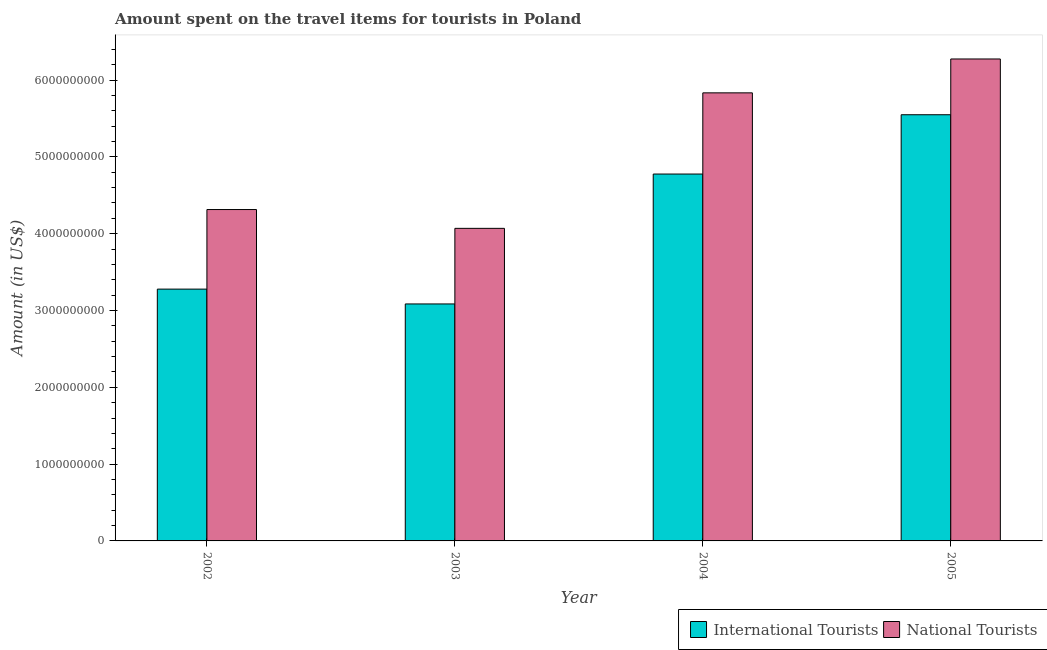Are the number of bars per tick equal to the number of legend labels?
Offer a terse response. Yes. Are the number of bars on each tick of the X-axis equal?
Your answer should be very brief. Yes. How many bars are there on the 1st tick from the left?
Your answer should be very brief. 2. How many bars are there on the 3rd tick from the right?
Your response must be concise. 2. What is the amount spent on travel items of national tourists in 2005?
Ensure brevity in your answer.  6.27e+09. Across all years, what is the maximum amount spent on travel items of national tourists?
Offer a terse response. 6.27e+09. Across all years, what is the minimum amount spent on travel items of international tourists?
Make the answer very short. 3.08e+09. In which year was the amount spent on travel items of international tourists maximum?
Provide a short and direct response. 2005. In which year was the amount spent on travel items of national tourists minimum?
Your response must be concise. 2003. What is the total amount spent on travel items of national tourists in the graph?
Keep it short and to the point. 2.05e+1. What is the difference between the amount spent on travel items of national tourists in 2003 and that in 2005?
Provide a succinct answer. -2.20e+09. What is the difference between the amount spent on travel items of national tourists in 2003 and the amount spent on travel items of international tourists in 2005?
Ensure brevity in your answer.  -2.20e+09. What is the average amount spent on travel items of national tourists per year?
Ensure brevity in your answer.  5.12e+09. In the year 2003, what is the difference between the amount spent on travel items of international tourists and amount spent on travel items of national tourists?
Offer a very short reply. 0. In how many years, is the amount spent on travel items of national tourists greater than 5000000000 US$?
Give a very brief answer. 2. What is the ratio of the amount spent on travel items of international tourists in 2002 to that in 2005?
Offer a terse response. 0.59. What is the difference between the highest and the second highest amount spent on travel items of national tourists?
Keep it short and to the point. 4.41e+08. What is the difference between the highest and the lowest amount spent on travel items of national tourists?
Keep it short and to the point. 2.20e+09. Is the sum of the amount spent on travel items of international tourists in 2004 and 2005 greater than the maximum amount spent on travel items of national tourists across all years?
Keep it short and to the point. Yes. What does the 2nd bar from the left in 2005 represents?
Give a very brief answer. National Tourists. What does the 1st bar from the right in 2004 represents?
Offer a terse response. National Tourists. How many years are there in the graph?
Offer a terse response. 4. What is the difference between two consecutive major ticks on the Y-axis?
Ensure brevity in your answer.  1.00e+09. Are the values on the major ticks of Y-axis written in scientific E-notation?
Your answer should be very brief. No. Does the graph contain grids?
Make the answer very short. No. How many legend labels are there?
Your answer should be compact. 2. What is the title of the graph?
Ensure brevity in your answer.  Amount spent on the travel items for tourists in Poland. Does "constant 2005 US$" appear as one of the legend labels in the graph?
Your answer should be very brief. No. What is the label or title of the X-axis?
Provide a short and direct response. Year. What is the Amount (in US$) in International Tourists in 2002?
Provide a succinct answer. 3.28e+09. What is the Amount (in US$) in National Tourists in 2002?
Give a very brief answer. 4.31e+09. What is the Amount (in US$) of International Tourists in 2003?
Give a very brief answer. 3.08e+09. What is the Amount (in US$) of National Tourists in 2003?
Offer a very short reply. 4.07e+09. What is the Amount (in US$) in International Tourists in 2004?
Keep it short and to the point. 4.78e+09. What is the Amount (in US$) of National Tourists in 2004?
Make the answer very short. 5.83e+09. What is the Amount (in US$) of International Tourists in 2005?
Give a very brief answer. 5.55e+09. What is the Amount (in US$) in National Tourists in 2005?
Your response must be concise. 6.27e+09. Across all years, what is the maximum Amount (in US$) in International Tourists?
Your answer should be compact. 5.55e+09. Across all years, what is the maximum Amount (in US$) in National Tourists?
Your answer should be very brief. 6.27e+09. Across all years, what is the minimum Amount (in US$) of International Tourists?
Your response must be concise. 3.08e+09. Across all years, what is the minimum Amount (in US$) in National Tourists?
Offer a terse response. 4.07e+09. What is the total Amount (in US$) of International Tourists in the graph?
Offer a terse response. 1.67e+1. What is the total Amount (in US$) of National Tourists in the graph?
Provide a succinct answer. 2.05e+1. What is the difference between the Amount (in US$) in International Tourists in 2002 and that in 2003?
Your response must be concise. 1.93e+08. What is the difference between the Amount (in US$) of National Tourists in 2002 and that in 2003?
Keep it short and to the point. 2.45e+08. What is the difference between the Amount (in US$) in International Tourists in 2002 and that in 2004?
Give a very brief answer. -1.50e+09. What is the difference between the Amount (in US$) of National Tourists in 2002 and that in 2004?
Give a very brief answer. -1.52e+09. What is the difference between the Amount (in US$) in International Tourists in 2002 and that in 2005?
Your response must be concise. -2.27e+09. What is the difference between the Amount (in US$) in National Tourists in 2002 and that in 2005?
Offer a terse response. -1.96e+09. What is the difference between the Amount (in US$) of International Tourists in 2003 and that in 2004?
Ensure brevity in your answer.  -1.69e+09. What is the difference between the Amount (in US$) of National Tourists in 2003 and that in 2004?
Your response must be concise. -1.76e+09. What is the difference between the Amount (in US$) in International Tourists in 2003 and that in 2005?
Your answer should be compact. -2.46e+09. What is the difference between the Amount (in US$) of National Tourists in 2003 and that in 2005?
Offer a terse response. -2.20e+09. What is the difference between the Amount (in US$) of International Tourists in 2004 and that in 2005?
Your answer should be compact. -7.72e+08. What is the difference between the Amount (in US$) of National Tourists in 2004 and that in 2005?
Provide a short and direct response. -4.41e+08. What is the difference between the Amount (in US$) of International Tourists in 2002 and the Amount (in US$) of National Tourists in 2003?
Keep it short and to the point. -7.91e+08. What is the difference between the Amount (in US$) in International Tourists in 2002 and the Amount (in US$) in National Tourists in 2004?
Provide a succinct answer. -2.56e+09. What is the difference between the Amount (in US$) in International Tourists in 2002 and the Amount (in US$) in National Tourists in 2005?
Provide a short and direct response. -3.00e+09. What is the difference between the Amount (in US$) in International Tourists in 2003 and the Amount (in US$) in National Tourists in 2004?
Provide a succinct answer. -2.75e+09. What is the difference between the Amount (in US$) in International Tourists in 2003 and the Amount (in US$) in National Tourists in 2005?
Ensure brevity in your answer.  -3.19e+09. What is the difference between the Amount (in US$) in International Tourists in 2004 and the Amount (in US$) in National Tourists in 2005?
Your answer should be very brief. -1.50e+09. What is the average Amount (in US$) of International Tourists per year?
Make the answer very short. 4.17e+09. What is the average Amount (in US$) in National Tourists per year?
Give a very brief answer. 5.12e+09. In the year 2002, what is the difference between the Amount (in US$) in International Tourists and Amount (in US$) in National Tourists?
Offer a very short reply. -1.04e+09. In the year 2003, what is the difference between the Amount (in US$) in International Tourists and Amount (in US$) in National Tourists?
Ensure brevity in your answer.  -9.84e+08. In the year 2004, what is the difference between the Amount (in US$) of International Tourists and Amount (in US$) of National Tourists?
Ensure brevity in your answer.  -1.06e+09. In the year 2005, what is the difference between the Amount (in US$) in International Tourists and Amount (in US$) in National Tourists?
Give a very brief answer. -7.26e+08. What is the ratio of the Amount (in US$) in International Tourists in 2002 to that in 2003?
Offer a terse response. 1.06. What is the ratio of the Amount (in US$) in National Tourists in 2002 to that in 2003?
Provide a short and direct response. 1.06. What is the ratio of the Amount (in US$) of International Tourists in 2002 to that in 2004?
Give a very brief answer. 0.69. What is the ratio of the Amount (in US$) of National Tourists in 2002 to that in 2004?
Keep it short and to the point. 0.74. What is the ratio of the Amount (in US$) of International Tourists in 2002 to that in 2005?
Your response must be concise. 0.59. What is the ratio of the Amount (in US$) in National Tourists in 2002 to that in 2005?
Your answer should be very brief. 0.69. What is the ratio of the Amount (in US$) of International Tourists in 2003 to that in 2004?
Make the answer very short. 0.65. What is the ratio of the Amount (in US$) of National Tourists in 2003 to that in 2004?
Provide a short and direct response. 0.7. What is the ratio of the Amount (in US$) in International Tourists in 2003 to that in 2005?
Offer a very short reply. 0.56. What is the ratio of the Amount (in US$) of National Tourists in 2003 to that in 2005?
Offer a terse response. 0.65. What is the ratio of the Amount (in US$) of International Tourists in 2004 to that in 2005?
Give a very brief answer. 0.86. What is the ratio of the Amount (in US$) in National Tourists in 2004 to that in 2005?
Your answer should be compact. 0.93. What is the difference between the highest and the second highest Amount (in US$) in International Tourists?
Provide a short and direct response. 7.72e+08. What is the difference between the highest and the second highest Amount (in US$) of National Tourists?
Your answer should be very brief. 4.41e+08. What is the difference between the highest and the lowest Amount (in US$) in International Tourists?
Your answer should be very brief. 2.46e+09. What is the difference between the highest and the lowest Amount (in US$) of National Tourists?
Give a very brief answer. 2.20e+09. 